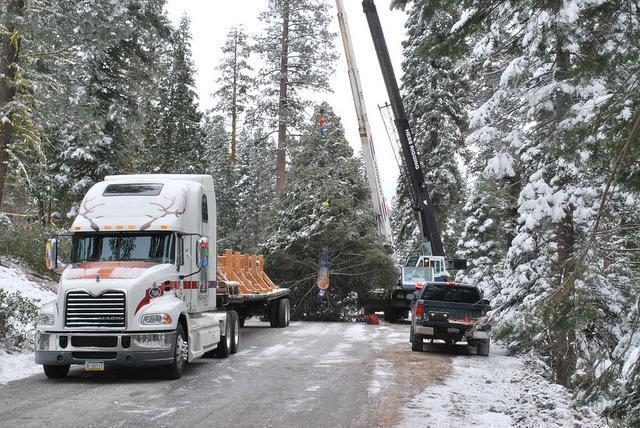What event is taking place here?
Indicate the correct response by choosing from the four available options to answer the question.
Options: Car accident, snow storm, logging, road construction. Logging. 